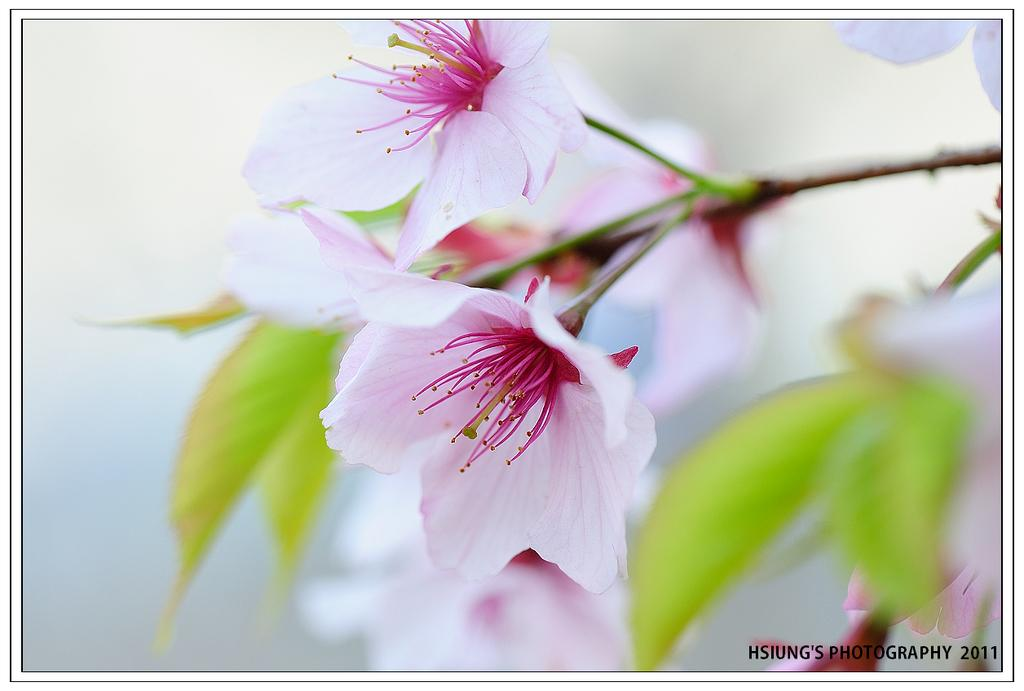What is the main subject of the image? The main subject of the image is flowers. Can you describe the flowers in the image? The flowers are pink in color. Are there any other elements associated with the flowers in the image? Yes, there are leaves associated with the flowers. How many eggs are visible in the image? There are no eggs present in the image; it features flowers and leaves. What type of insurance policy is being advertised in the image? There is no insurance policy being advertised in the image; it features flowers and leaves. 